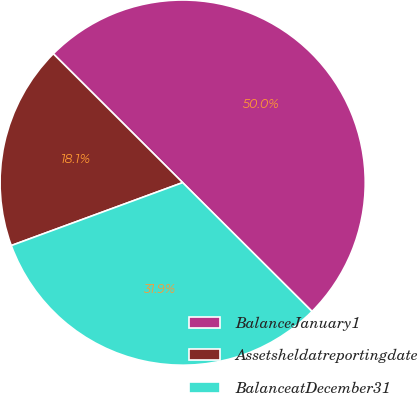Convert chart to OTSL. <chart><loc_0><loc_0><loc_500><loc_500><pie_chart><fcel>BalanceJanuary1<fcel>Assetsheldatreportingdate<fcel>BalanceatDecember31<nl><fcel>50.0%<fcel>18.07%<fcel>31.93%<nl></chart> 